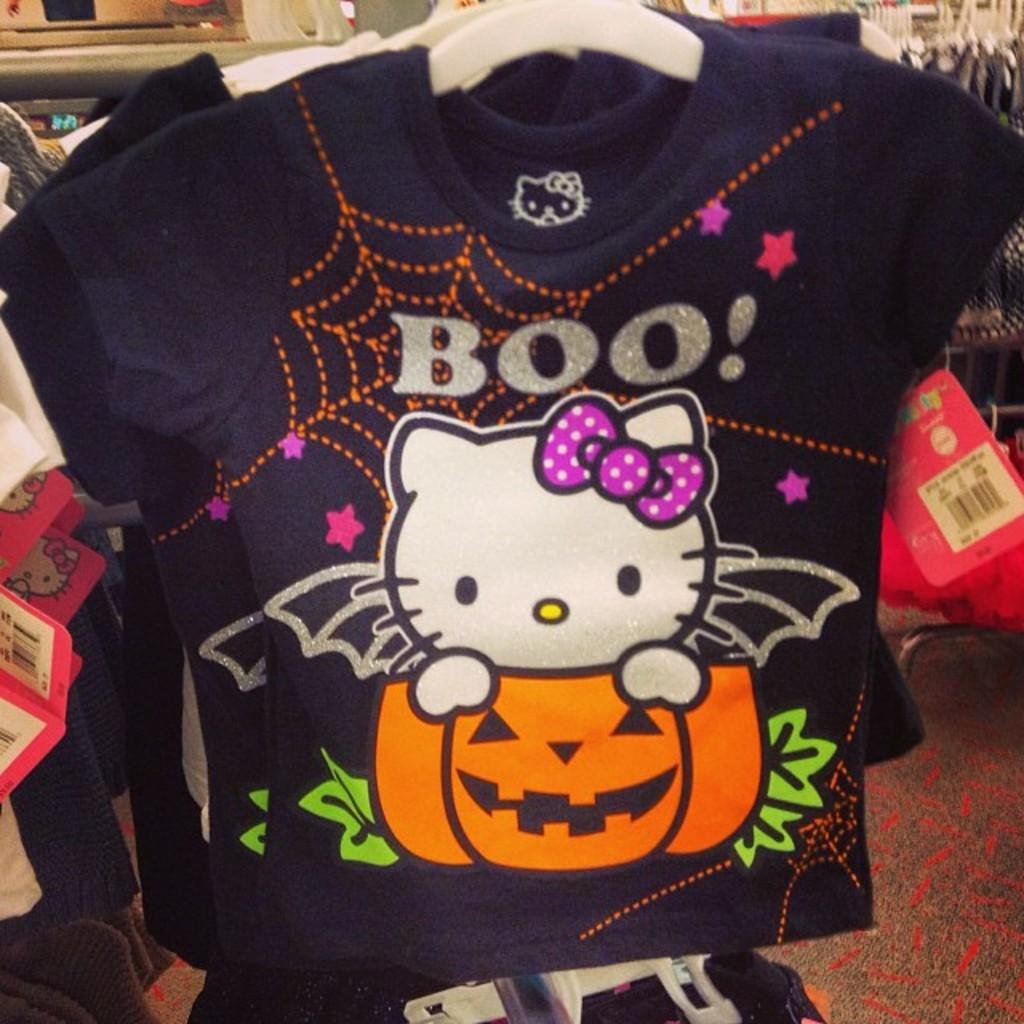What is hanging on the stand in the image? There are dresses hanged on hangers in the image. What are the hangers attached to? The hangers are on a stand. What additional information is provided on the dresses? Rate cards are hanged on the dresses. What type of flooring is visible in the image? There is a carpet on the floor. What type of comb is used to style the bear's fur in the image? There is no bear present in the image, and therefore no comb or fur to style. 